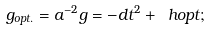<formula> <loc_0><loc_0><loc_500><loc_500>g _ { o p t . } = a ^ { - 2 } g = - d t ^ { 2 } + \ h o p t ;</formula> 